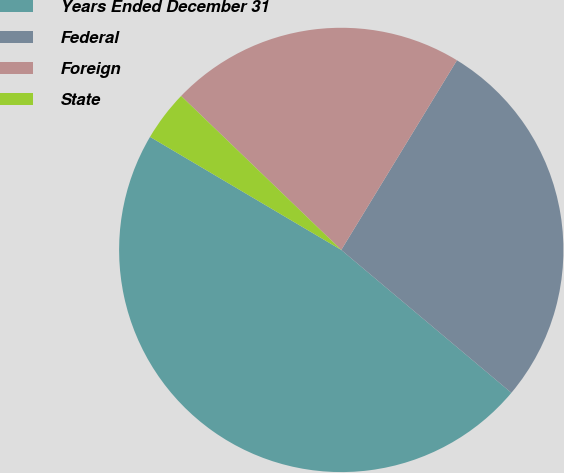<chart> <loc_0><loc_0><loc_500><loc_500><pie_chart><fcel>Years Ended December 31<fcel>Federal<fcel>Foreign<fcel>State<nl><fcel>47.38%<fcel>27.4%<fcel>21.53%<fcel>3.69%<nl></chart> 